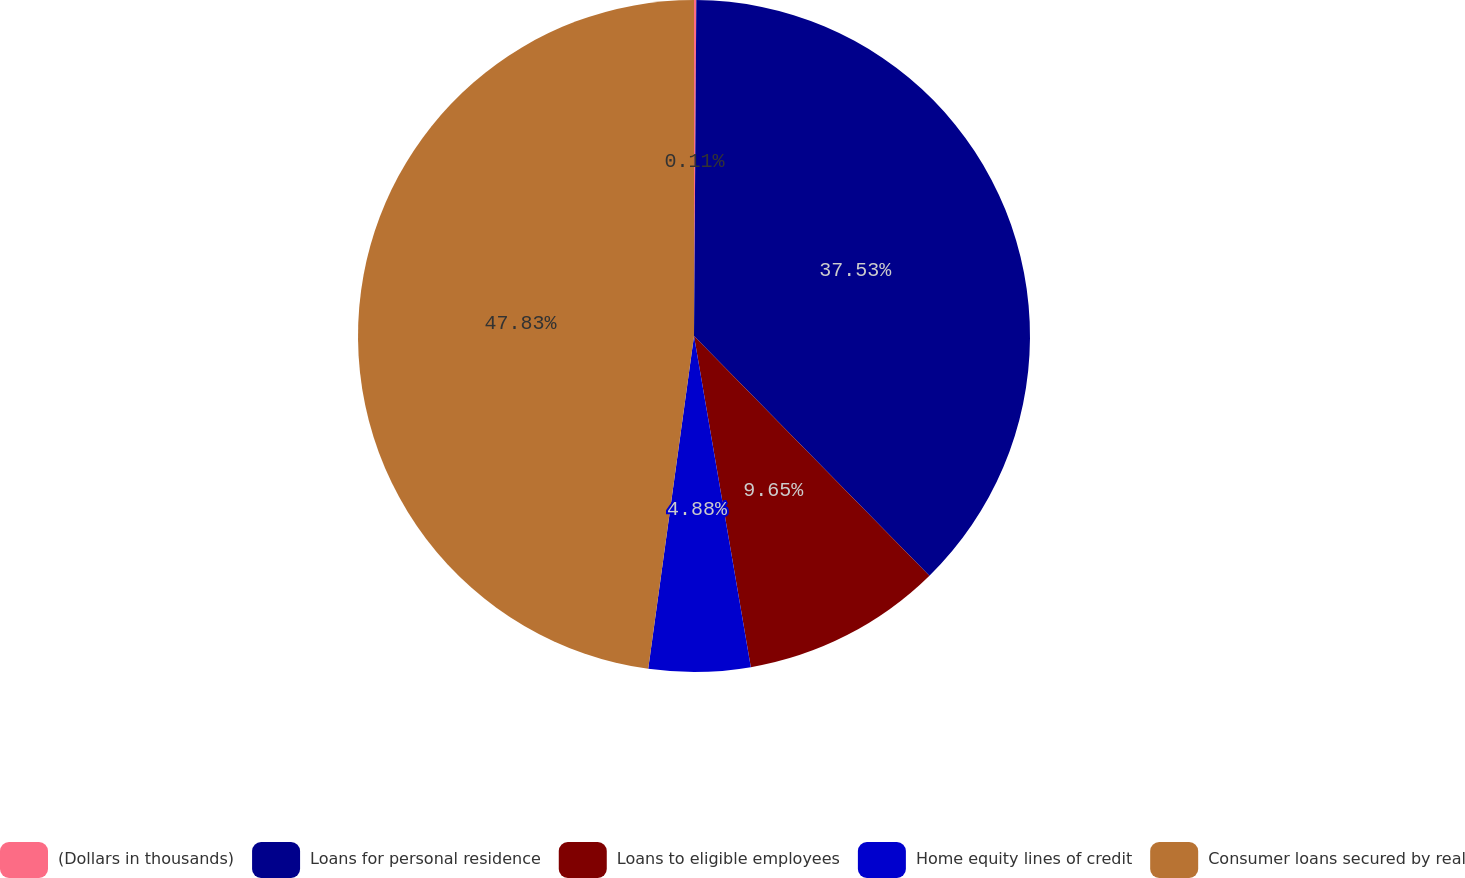<chart> <loc_0><loc_0><loc_500><loc_500><pie_chart><fcel>(Dollars in thousands)<fcel>Loans for personal residence<fcel>Loans to eligible employees<fcel>Home equity lines of credit<fcel>Consumer loans secured by real<nl><fcel>0.11%<fcel>37.53%<fcel>9.65%<fcel>4.88%<fcel>47.82%<nl></chart> 